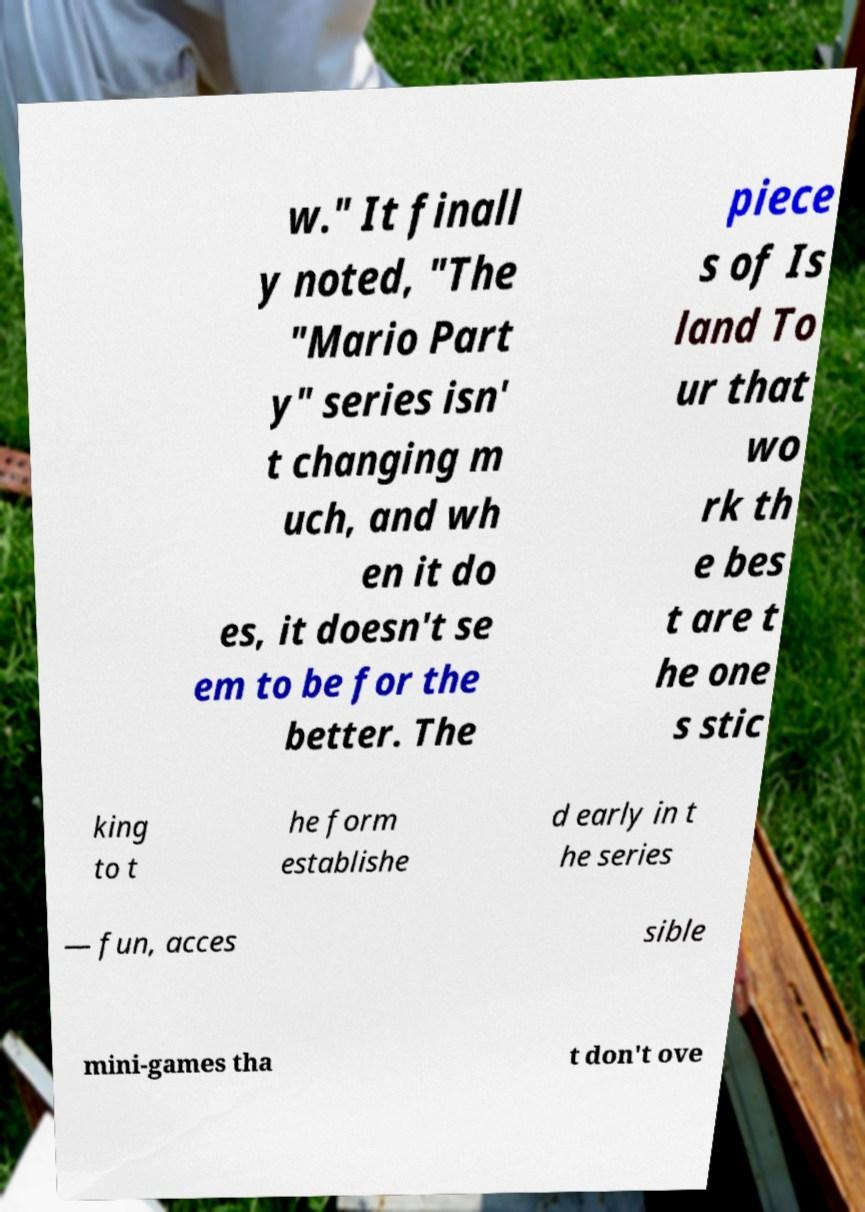I need the written content from this picture converted into text. Can you do that? w." It finall y noted, "The "Mario Part y" series isn' t changing m uch, and wh en it do es, it doesn't se em to be for the better. The piece s of Is land To ur that wo rk th e bes t are t he one s stic king to t he form establishe d early in t he series — fun, acces sible mini-games tha t don't ove 